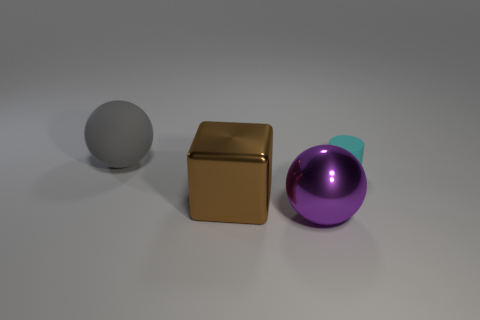Is there anything else that is the same size as the cylinder?
Your response must be concise. No. What number of shiny objects are either tiny cyan cylinders or brown things?
Ensure brevity in your answer.  1. There is a big sphere in front of the large object that is left of the brown object; are there any cyan matte cylinders left of it?
Your answer should be compact. No. What size is the other thing that is the same material as the big gray thing?
Your response must be concise. Small. There is a big purple metal ball; are there any large gray balls in front of it?
Provide a succinct answer. No. Are there any tiny cyan matte cylinders that are on the right side of the big sphere in front of the large gray sphere?
Your answer should be compact. Yes. Is the size of the shiny thing behind the purple object the same as the sphere in front of the large matte sphere?
Provide a succinct answer. Yes. What number of small objects are either purple metal spheres or cyan cylinders?
Offer a very short reply. 1. There is a cyan object on the right side of the matte object to the left of the cyan rubber thing; what is its material?
Make the answer very short. Rubber. Is there a purple thing made of the same material as the big gray object?
Provide a short and direct response. No. 